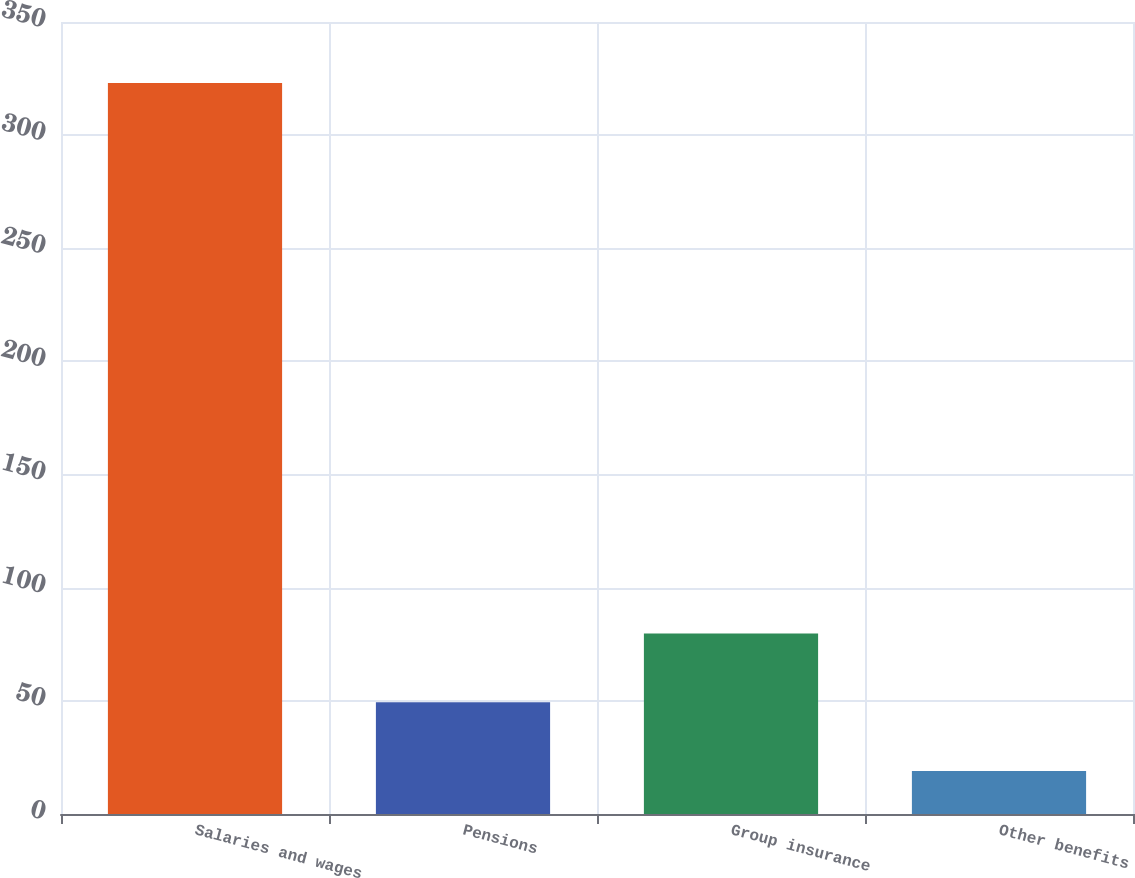Convert chart to OTSL. <chart><loc_0><loc_0><loc_500><loc_500><bar_chart><fcel>Salaries and wages<fcel>Pensions<fcel>Group insurance<fcel>Other benefits<nl><fcel>323<fcel>49.4<fcel>79.8<fcel>19<nl></chart> 